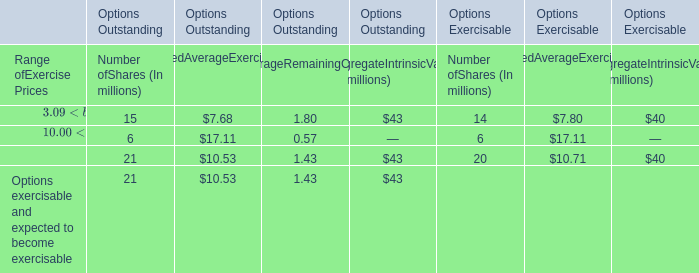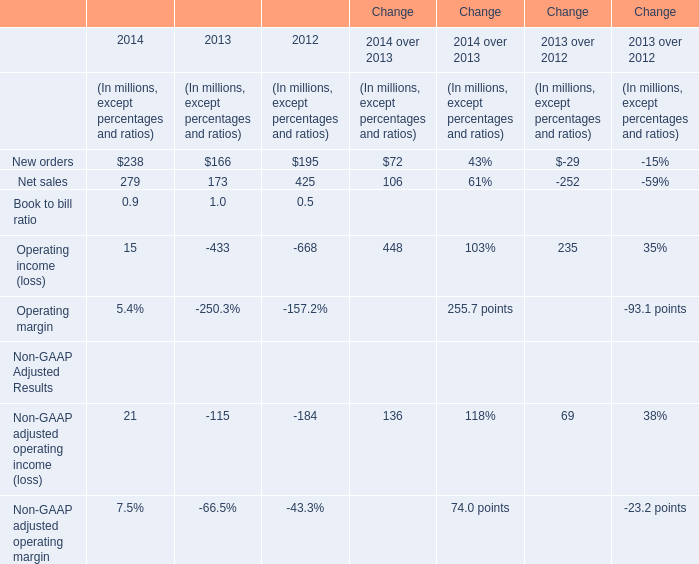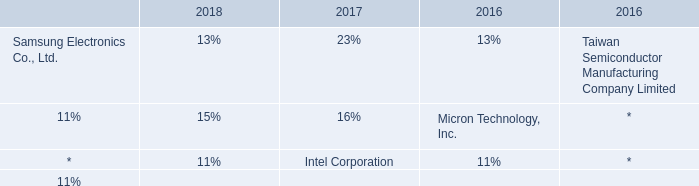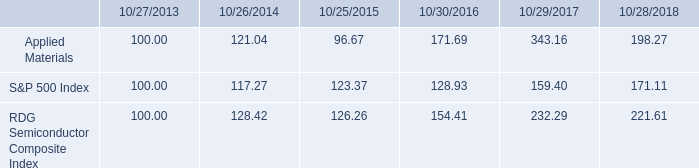In the year with the most new orders, what is the growth rate of net sales? 
Computations: ((279 - 173) / 173)
Answer: 0.61272. 